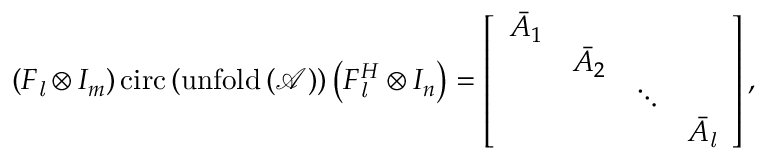<formula> <loc_0><loc_0><loc_500><loc_500>\left ( F _ { l } \otimes I _ { m } \right ) c i r c \left ( u n f o l d \left ( \mathcal { A } \right ) \right ) \left ( F _ { l } ^ { H } \otimes I _ { n } \right ) = \left [ \begin{array} { l l l l } { \bar { A } _ { 1 } } & & & \\ & { \bar { A } _ { 2 } } & & \\ & & { \ddots } & \\ & & & { \bar { A } _ { l } } \end{array} \right ] ,</formula> 